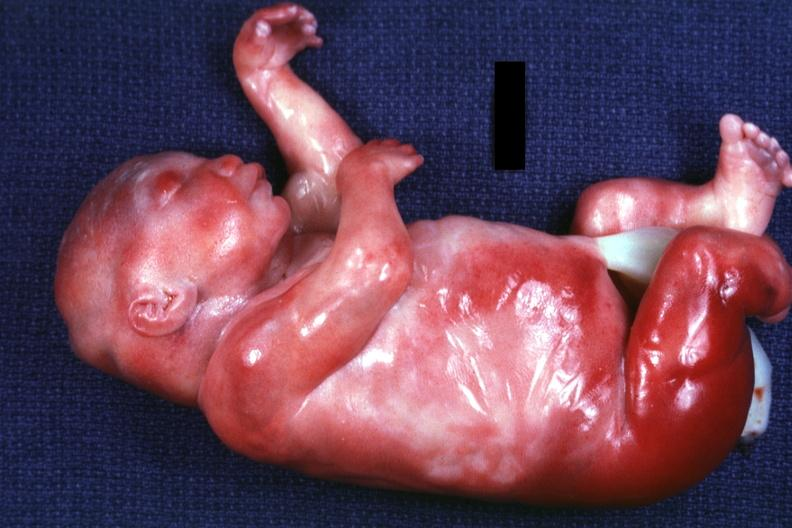what does this image show?
Answer the question using a single word or phrase. Lateral view of body with renal facies no neck 